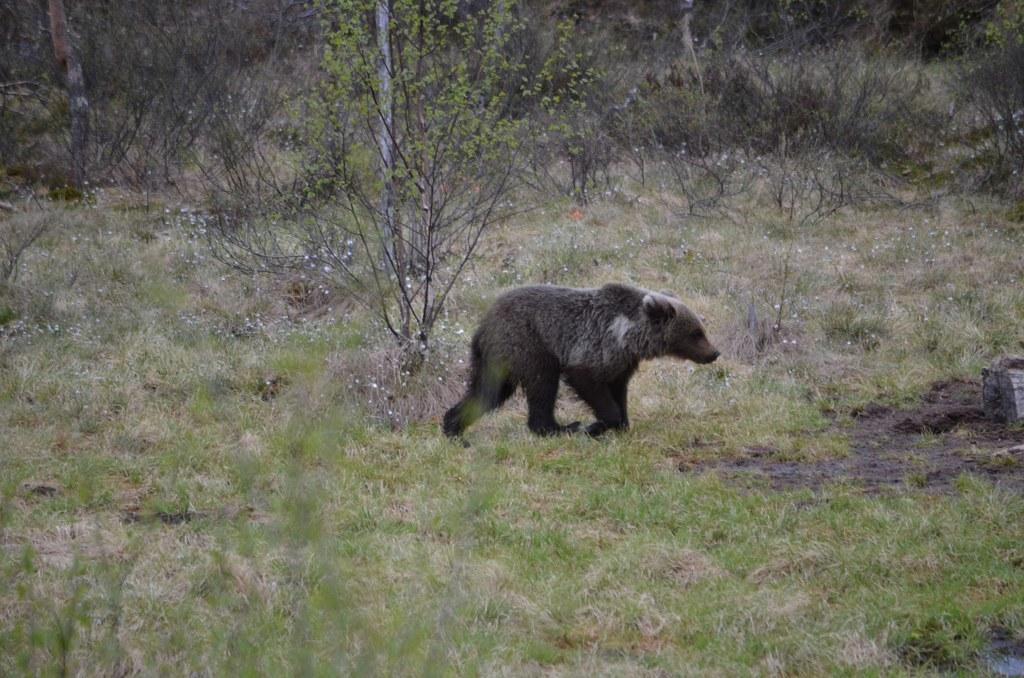What type of creature is in the image? There is an animal in the image. Where is the animal located? The animal is on the ground. What can be seen in the background of the image? There is grass and trees in the background of the image. What word is the animal spelling out with its feet in the image? There is no indication that the animal is spelling out a word with its feet in the image. 